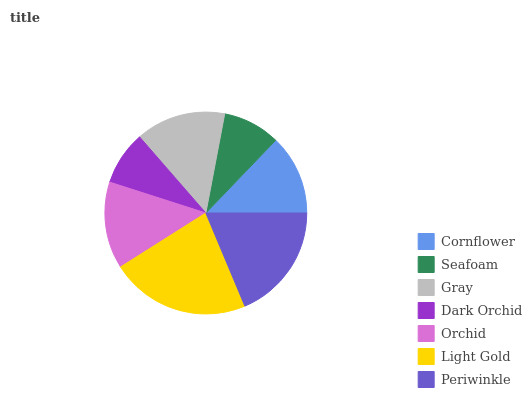Is Dark Orchid the minimum?
Answer yes or no. Yes. Is Light Gold the maximum?
Answer yes or no. Yes. Is Seafoam the minimum?
Answer yes or no. No. Is Seafoam the maximum?
Answer yes or no. No. Is Cornflower greater than Seafoam?
Answer yes or no. Yes. Is Seafoam less than Cornflower?
Answer yes or no. Yes. Is Seafoam greater than Cornflower?
Answer yes or no. No. Is Cornflower less than Seafoam?
Answer yes or no. No. Is Orchid the high median?
Answer yes or no. Yes. Is Orchid the low median?
Answer yes or no. Yes. Is Dark Orchid the high median?
Answer yes or no. No. Is Cornflower the low median?
Answer yes or no. No. 